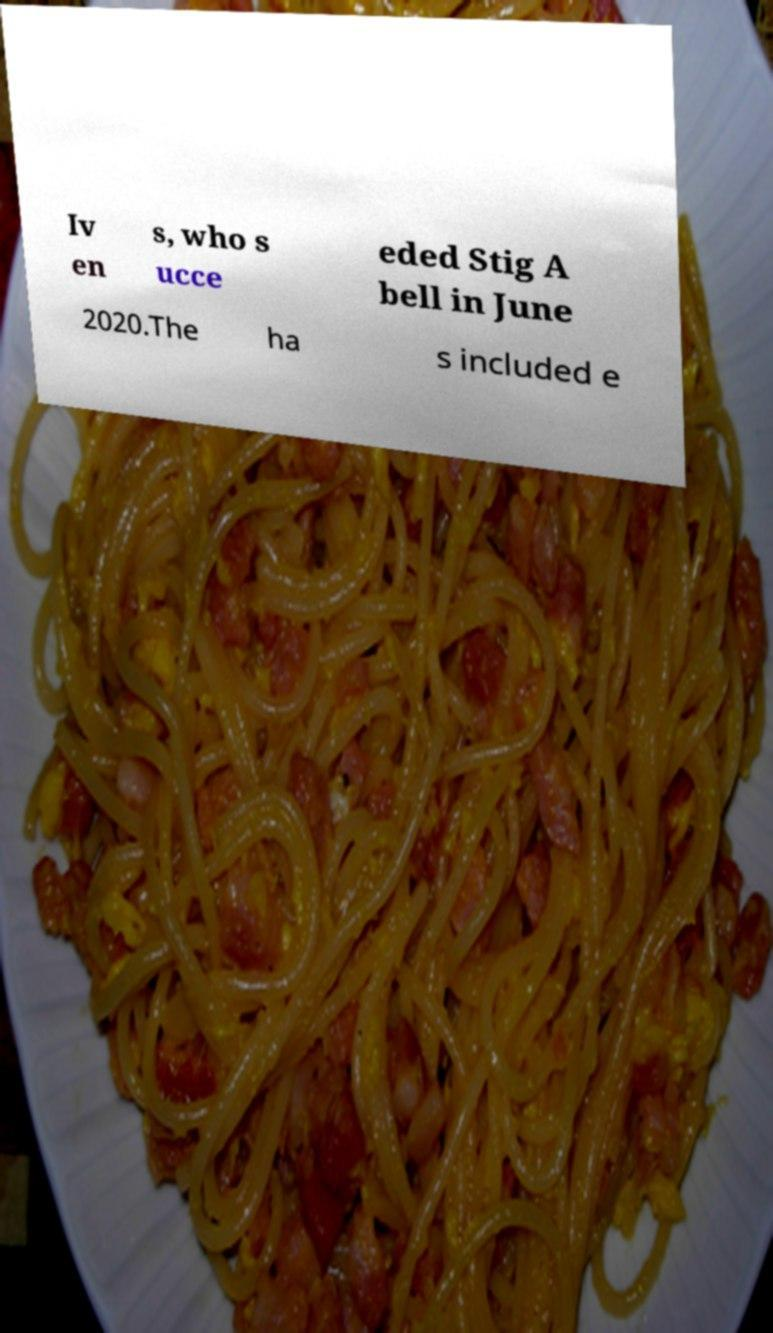I need the written content from this picture converted into text. Can you do that? Iv en s, who s ucce eded Stig A bell in June 2020.The ha s included e 